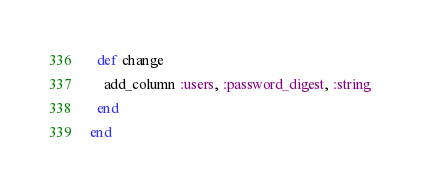Convert code to text. <code><loc_0><loc_0><loc_500><loc_500><_Ruby_>  def change
    add_column :users, :password_digest, :string
  end  
end
</code> 